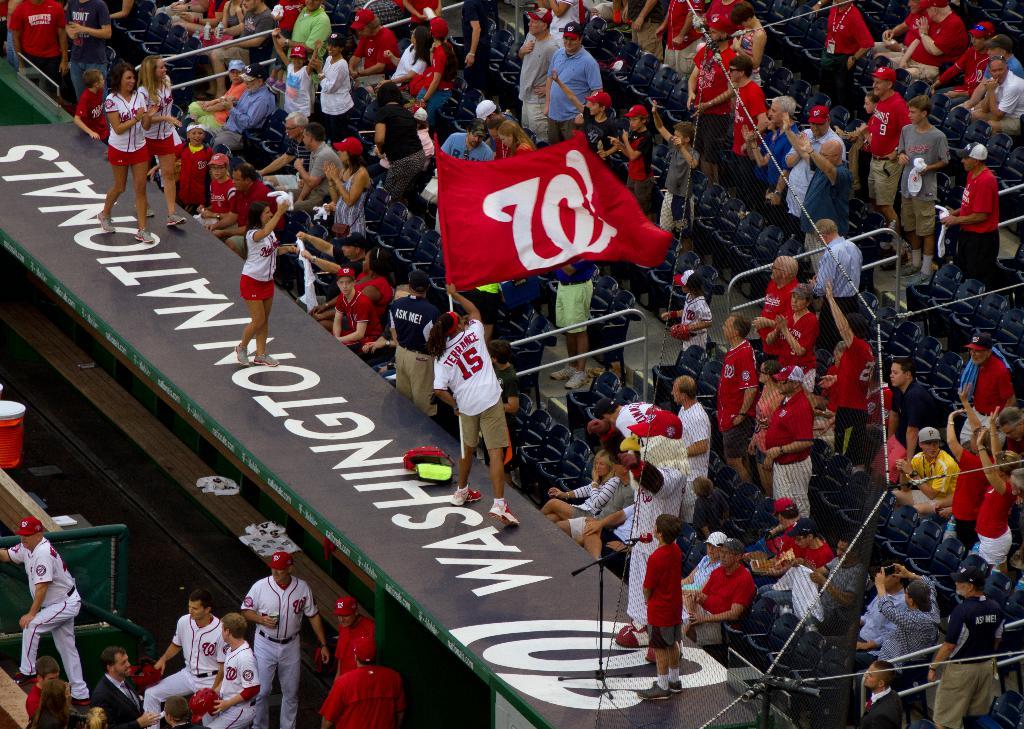What is written on top of the dugout?
Offer a terse response. Washington nationals. 